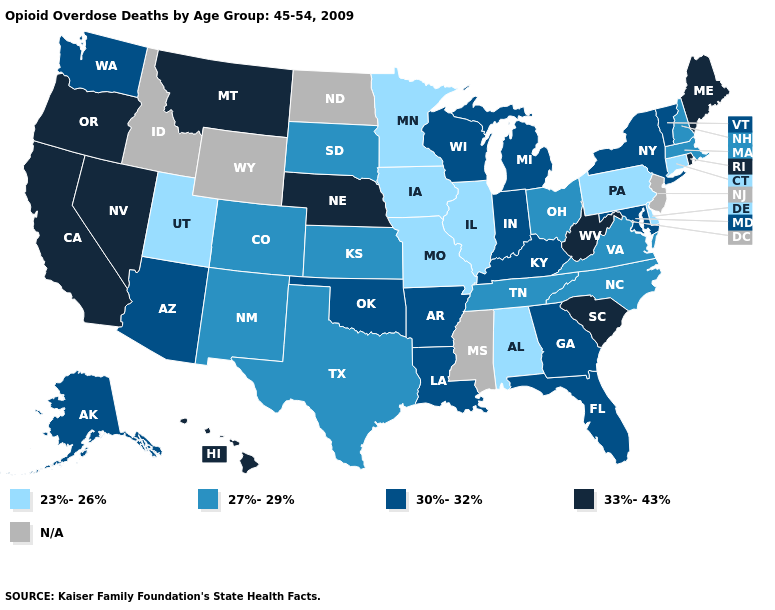Does Delaware have the lowest value in the USA?
Keep it brief. Yes. What is the value of South Dakota?
Give a very brief answer. 27%-29%. Among the states that border Massachusetts , which have the lowest value?
Answer briefly. Connecticut. Among the states that border Pennsylvania , which have the lowest value?
Short answer required. Delaware. What is the value of Nevada?
Quick response, please. 33%-43%. Among the states that border Oregon , which have the lowest value?
Quick response, please. Washington. What is the value of California?
Keep it brief. 33%-43%. Which states have the lowest value in the USA?
Quick response, please. Alabama, Connecticut, Delaware, Illinois, Iowa, Minnesota, Missouri, Pennsylvania, Utah. Name the states that have a value in the range N/A?
Short answer required. Idaho, Mississippi, New Jersey, North Dakota, Wyoming. What is the lowest value in states that border Missouri?
Give a very brief answer. 23%-26%. What is the value of Virginia?
Answer briefly. 27%-29%. How many symbols are there in the legend?
Be succinct. 5. What is the value of Delaware?
Quick response, please. 23%-26%. What is the highest value in the MidWest ?
Be succinct. 33%-43%. 